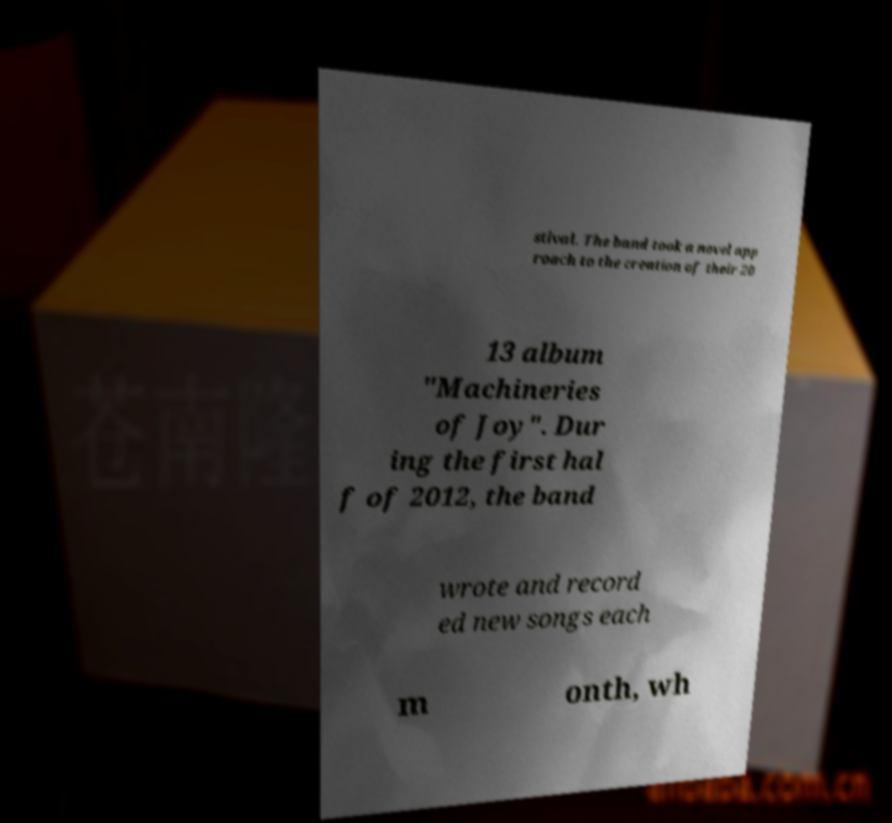What messages or text are displayed in this image? I need them in a readable, typed format. stival. The band took a novel app roach to the creation of their 20 13 album "Machineries of Joy". Dur ing the first hal f of 2012, the band wrote and record ed new songs each m onth, wh 